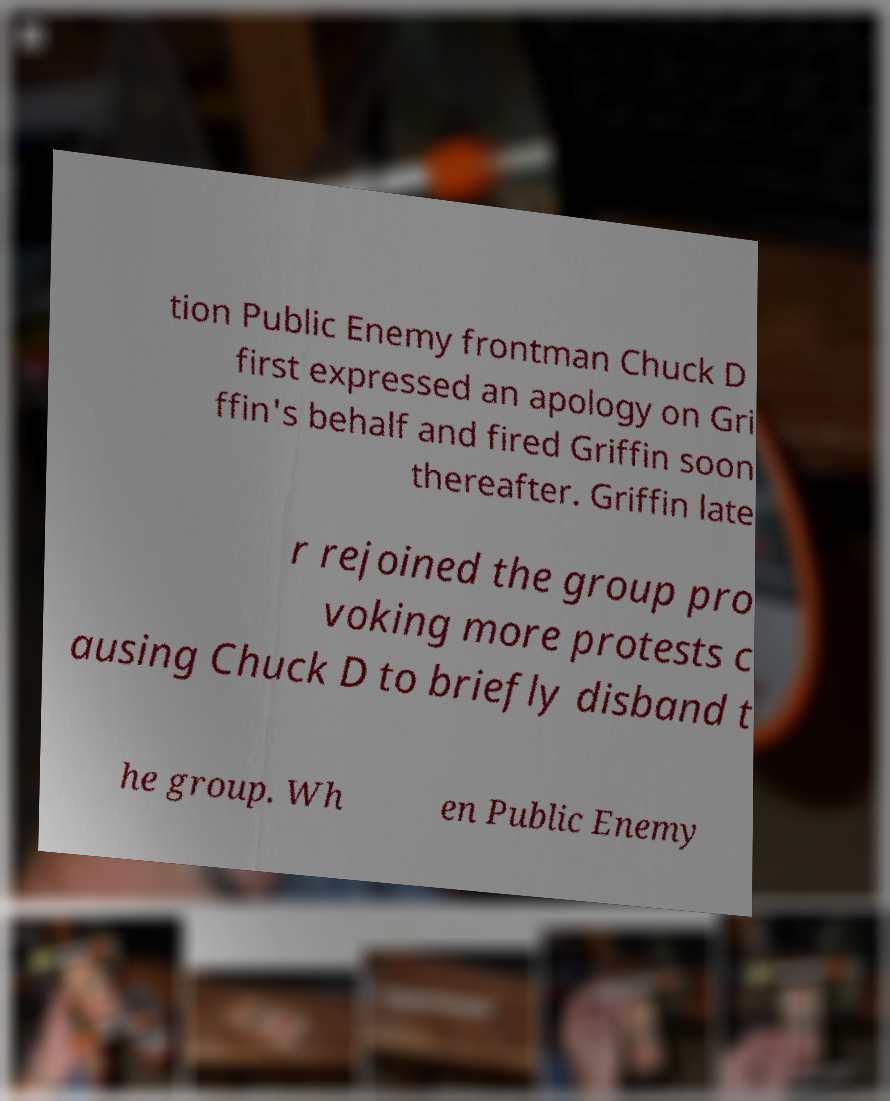Please identify and transcribe the text found in this image. tion Public Enemy frontman Chuck D first expressed an apology on Gri ffin's behalf and fired Griffin soon thereafter. Griffin late r rejoined the group pro voking more protests c ausing Chuck D to briefly disband t he group. Wh en Public Enemy 